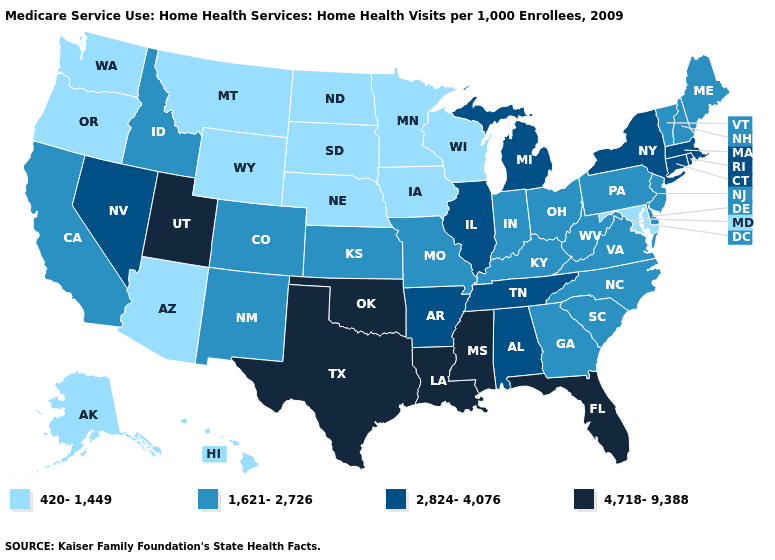Does Oregon have the lowest value in the USA?
Give a very brief answer. Yes. What is the highest value in the South ?
Quick response, please. 4,718-9,388. Name the states that have a value in the range 2,824-4,076?
Keep it brief. Alabama, Arkansas, Connecticut, Illinois, Massachusetts, Michigan, Nevada, New York, Rhode Island, Tennessee. What is the value of Texas?
Write a very short answer. 4,718-9,388. Name the states that have a value in the range 4,718-9,388?
Concise answer only. Florida, Louisiana, Mississippi, Oklahoma, Texas, Utah. What is the lowest value in states that border West Virginia?
Quick response, please. 420-1,449. What is the value of New Hampshire?
Answer briefly. 1,621-2,726. Does Tennessee have a lower value than Oklahoma?
Answer briefly. Yes. Is the legend a continuous bar?
Answer briefly. No. Does Arkansas have the lowest value in the South?
Answer briefly. No. Does Utah have the highest value in the West?
Concise answer only. Yes. What is the value of Georgia?
Keep it brief. 1,621-2,726. What is the highest value in states that border Pennsylvania?
Write a very short answer. 2,824-4,076. What is the value of Pennsylvania?
Concise answer only. 1,621-2,726. Name the states that have a value in the range 1,621-2,726?
Give a very brief answer. California, Colorado, Delaware, Georgia, Idaho, Indiana, Kansas, Kentucky, Maine, Missouri, New Hampshire, New Jersey, New Mexico, North Carolina, Ohio, Pennsylvania, South Carolina, Vermont, Virginia, West Virginia. 